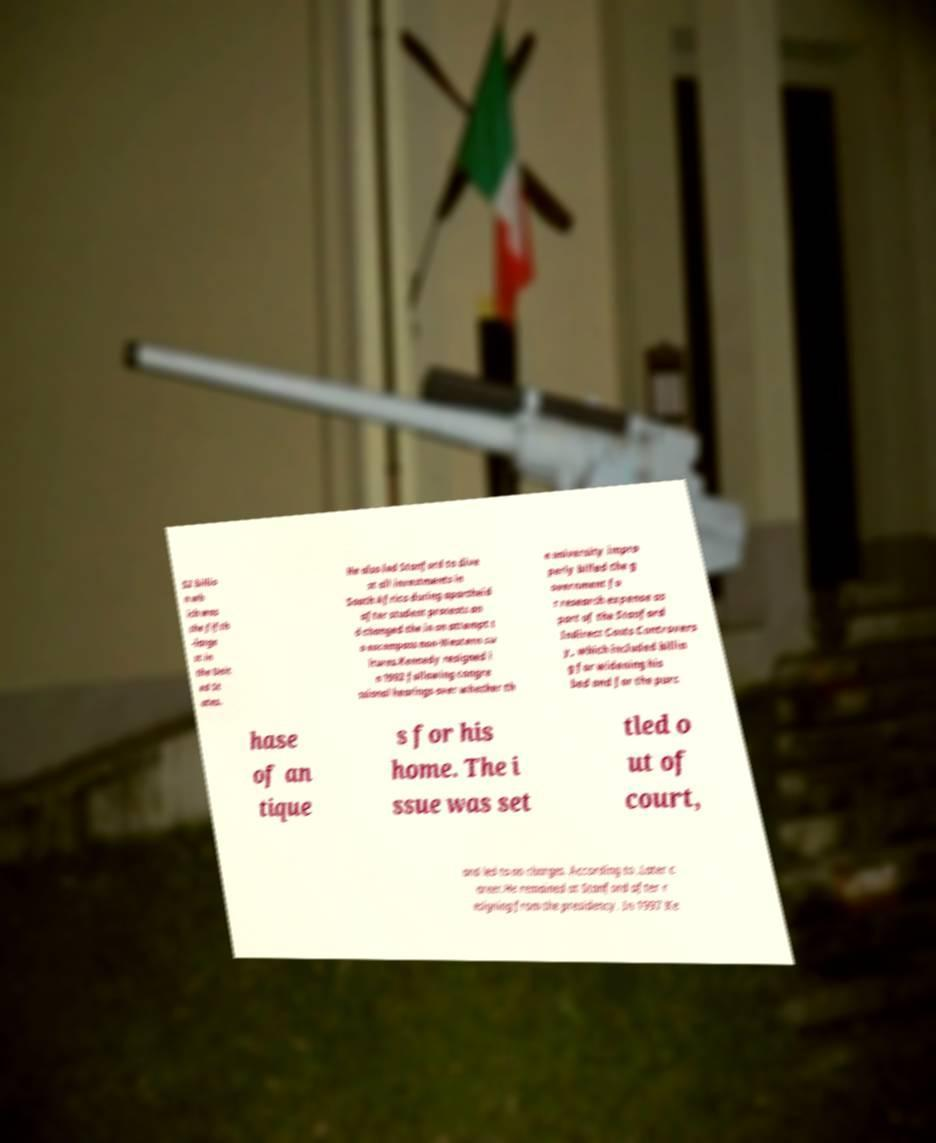Could you assist in decoding the text presented in this image and type it out clearly? $2 billio n wh ich was the fifth -large st in the Unit ed St ates. He also led Stanford to dive st all investments in South Africa during apartheid after student protests an d changed the in an attempt t o encompass non-Western cu ltures.Kennedy resigned i n 1992 following congre ssional hearings over whether th e university impro perly billed the g overnment fo r research expense as part of the Stanford Indirect Costs Controvers y, which included billin g for widening his bed and for the purc hase of an tique s for his home. The i ssue was set tled o ut of court, and led to no charges. According to .Later c areer.He remained at Stanford after r esigning from the presidency. In 1997 Ke 